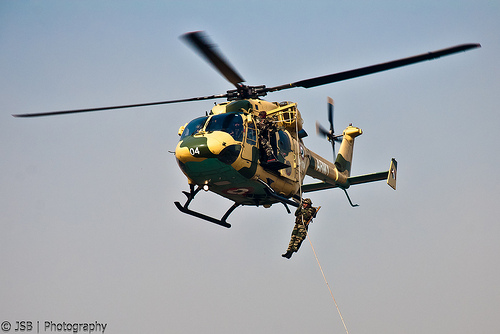<image>
Is the helicopter above the sky? No. The helicopter is not positioned above the sky. The vertical arrangement shows a different relationship. 